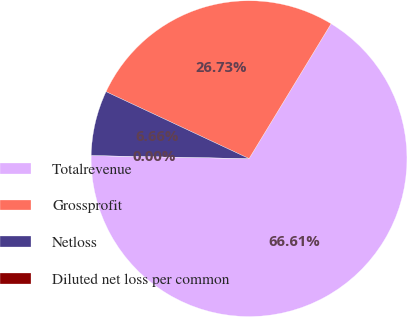Convert chart to OTSL. <chart><loc_0><loc_0><loc_500><loc_500><pie_chart><fcel>Totalrevenue<fcel>Grossprofit<fcel>Netloss<fcel>Diluted net loss per common<nl><fcel>66.61%<fcel>26.73%<fcel>6.66%<fcel>0.0%<nl></chart> 